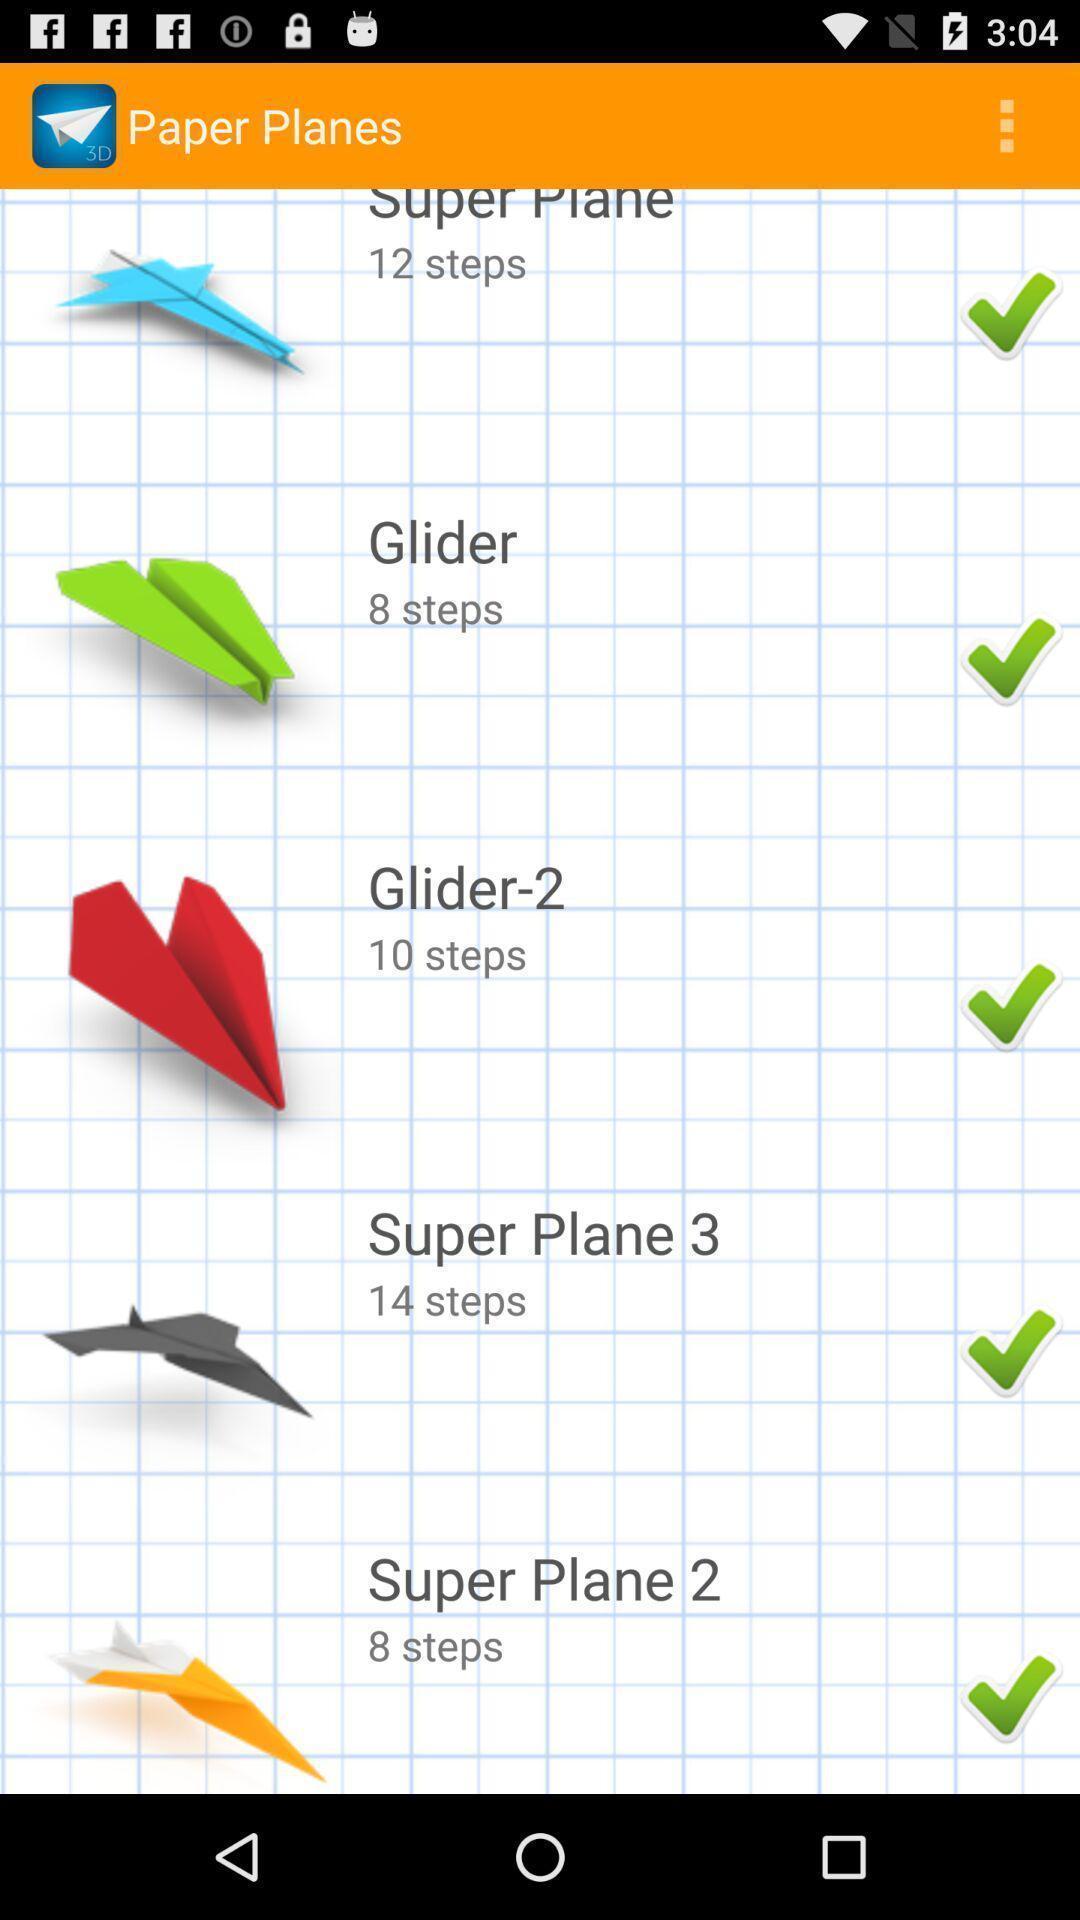Please provide a description for this image. Page with various plane options to learn using steps. 